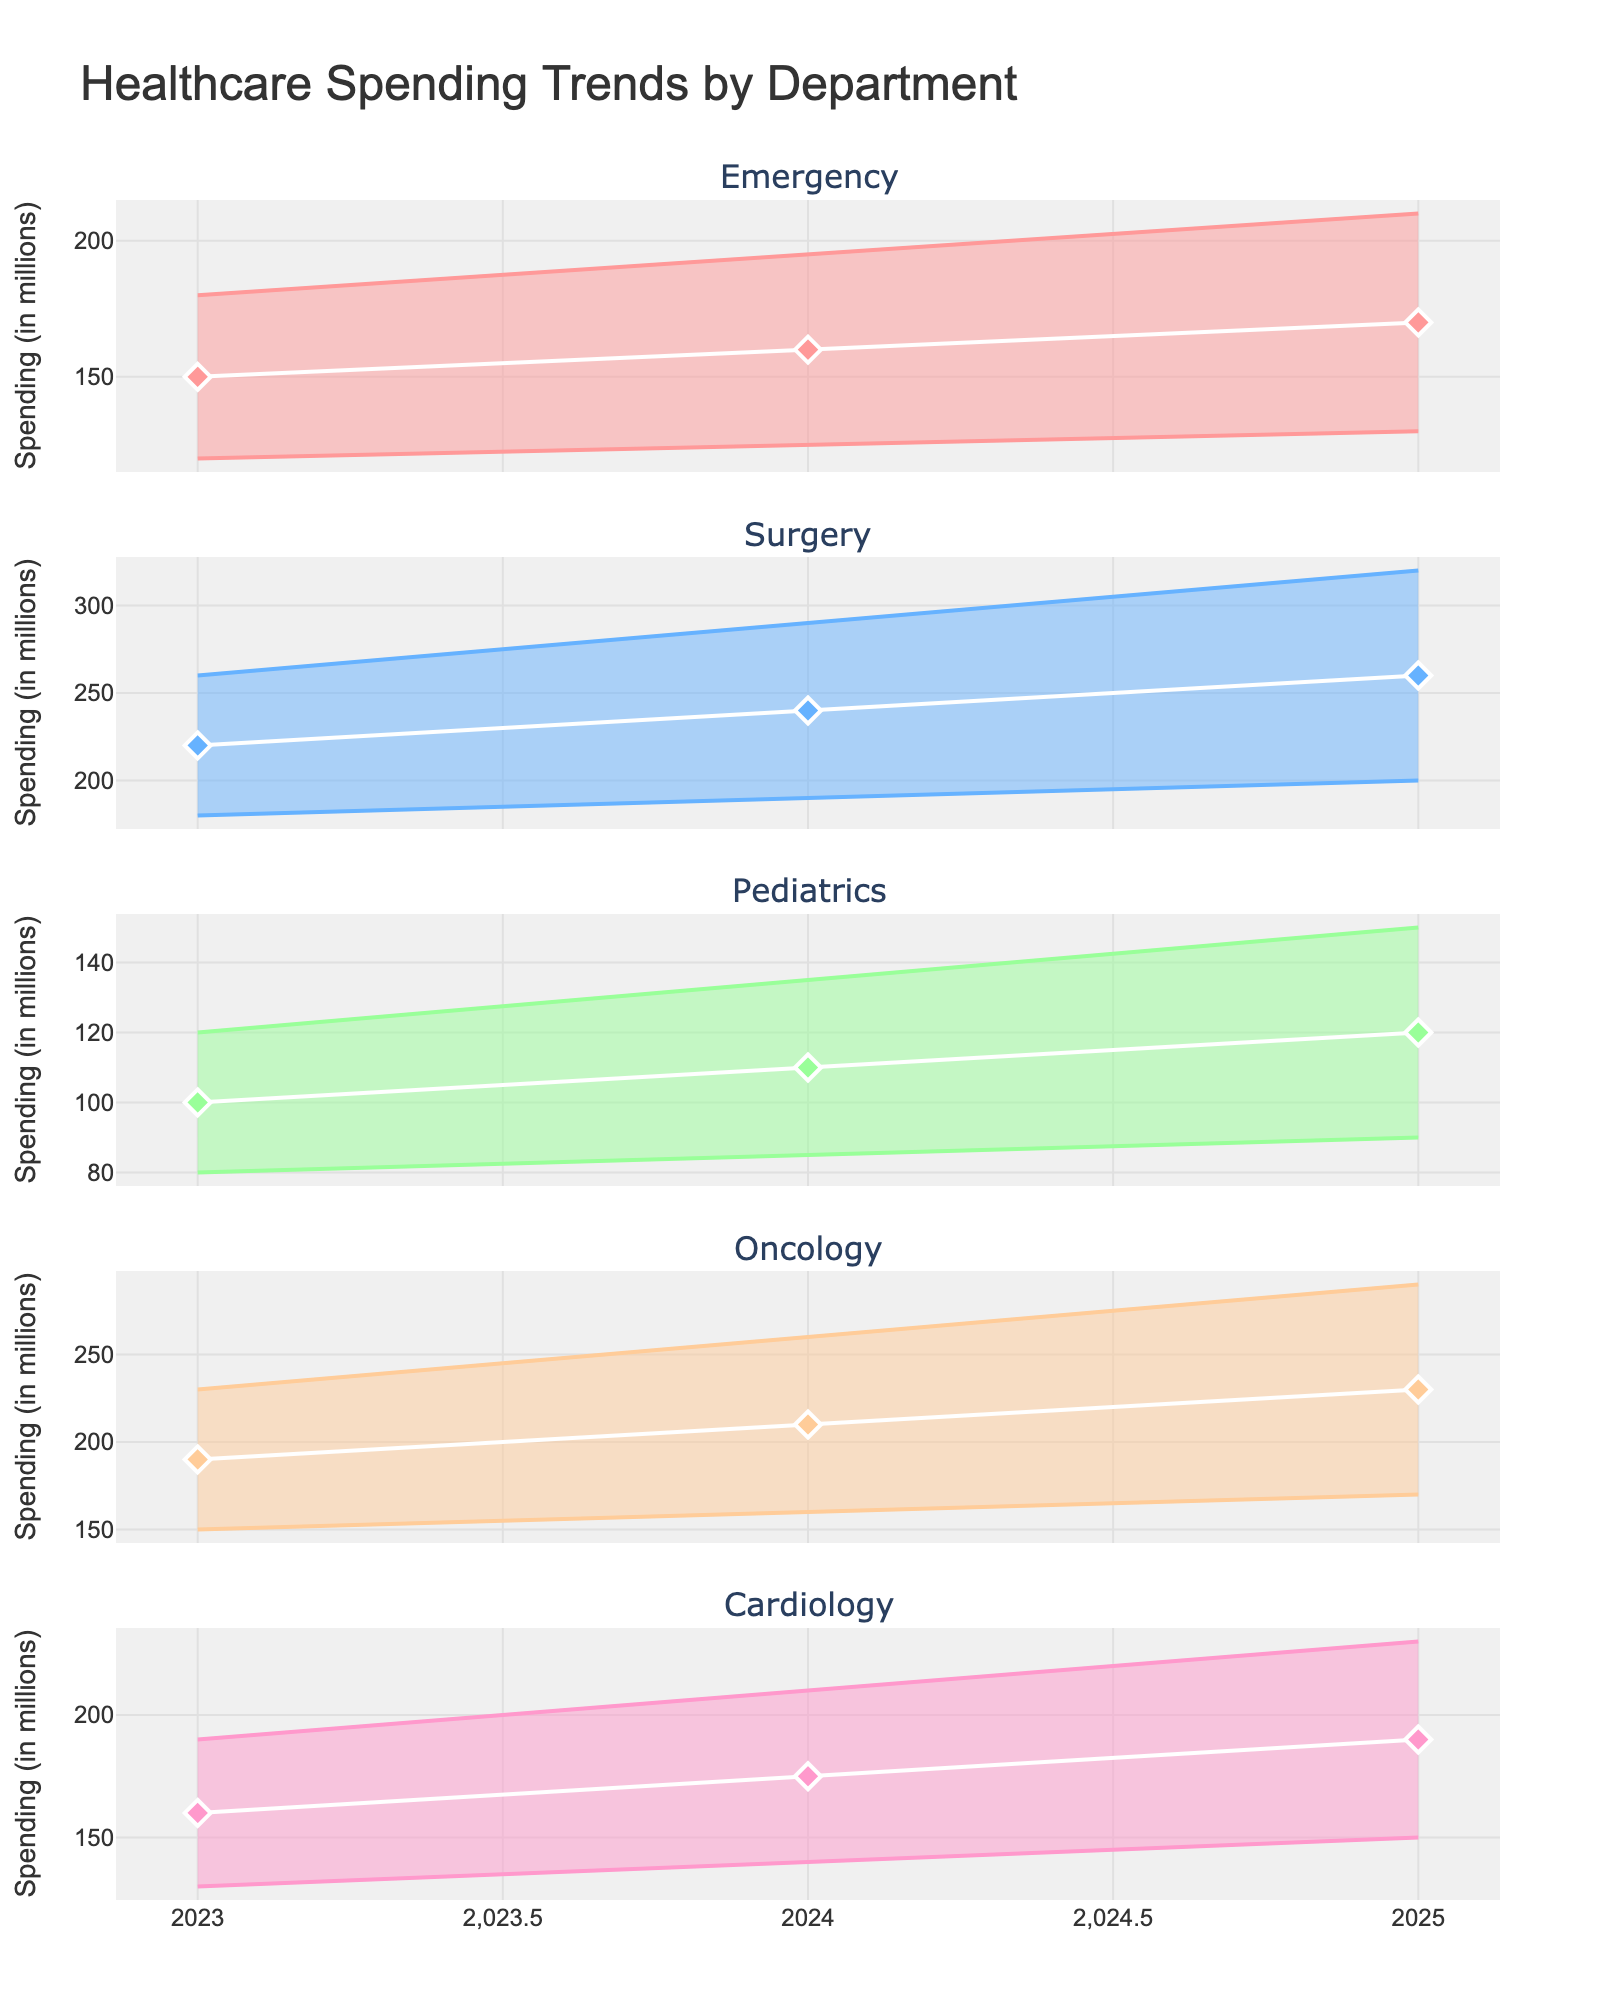What's the title of the figure? The title is located at the top center of the figure, often indicating the main subject of the chart. In this case, it's "Healthcare Spending Trends by Department".
Answer: Healthcare Spending Trends by Department Which department has the highest median spending in 2024? Locate the medians for each department in 2024 from the visual representation. Surgery has the highest median spending, positioned higher than others on the y-axis.
Answer: Surgery How does the median spending in Pediatrics change from 2023 to 2025? Compare the median dots for Pediatrics for the years 2023 and 2025. The median in Pediatrics increases from 100 in 2023 to 120 in 2025.
Answer: It increases Which department has the widest uncertainty range in 2025? The uncertainty range is represented by the shaded area between the lower and upper bounds. Surgery has the widest range in 2025 as the gap between upper and lower bounds is the greatest.
Answer: Surgery Compare the upper bounds of Oncology and Cardiology in 2025. Which is higher? Identify the upper bounds for both departments in 2025 and compare their heights on the y-axis. Oncology's upper bound is higher than that of Cardiology.
Answer: Oncology What is the median spending trend in Emergency from 2023 to 2025? Check the position of the median dots for Emergency from 2023 to 2025. The spending increases from 150 in 2023 to 170 in 2025.
Answer: It increases What's the difference in the median spending between Surgery and Pediatrics in 2024? Subtract the median spending of Pediatrics (110) from Surgery (240) for the year 2024. 240 - 110 = 130.
Answer: 130 Which department shows the smallest increase in lower bound spending from 2023 to 2025? Calculate the difference in lower bounds from 2023 to 2025 for each department. Pediatrics has the smallest increase (90 to 105), which is 15.
Answer: Pediatrics Is the uncertainty range for Cardiology in 2023 smaller or larger than in 2024? Compare the shaded areas representing the uncertainty ranges between 2023 and 2024 for Cardiology. The range is slightly larger in 2024.
Answer: Larger Which year shows the highest median spending for Oncology? Identify the median dots for Oncology across the years and find the highest one. 2025 shows the highest median spending.
Answer: 2025 